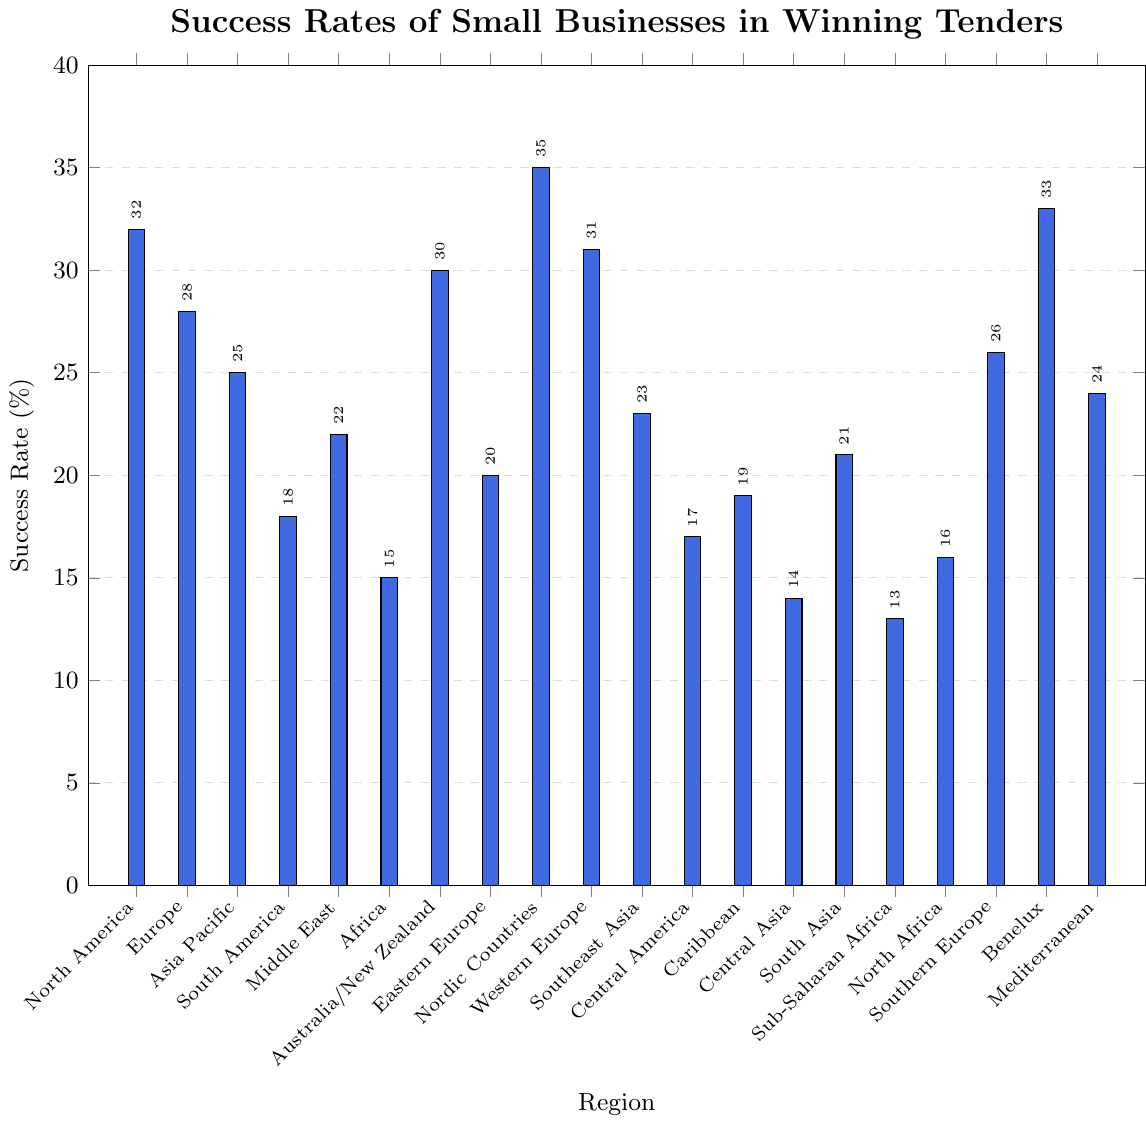Which region has the highest success rate in winning tenders? By looking at the tallest bar, we can identify the region with the highest success rate. The Nordic Countries have the tallest bar, indicating the highest success rate.
Answer: Nordic Countries Which regions have a success rate lower than 20%? To answer this, we compare the heights of the bars with the 20% mark. The regions with bars shorter than the 20% mark are South America, Africa, Eastern Europe, Central America, Central Asia, Sub-Saharan Africa, and North Africa.
Answer: South America, Africa, Eastern Europe, Central America, Central Asia, Sub-Saharan Africa, North Africa What is the combined success rate for North America and Benelux? The success rates for North America and Benelux are 32% and 33% respectively. Adding these values: 32 + 33 = 65.
Answer: 65% Which region has the lowest success rate and what is it? By identifying the shortest bar, we can determine the region with the lowest success rate. Sub-Saharan Africa has the shortest bar with a success rate of 13%.
Answer: Sub-Saharan Africa with 13% Are there more regions with success rates above or below 25%? We count the number of regions with bars taller than 25% and those with bars shorter than 25%. Regions above 25%: North America, Europe, Australia/New Zealand, Nordic Countries, Western Europe, Benelux, Southern Europe. Regions below 25%: Asia Pacific, South America, Middle East, Africa, Eastern Europe, Southeast Asia, Central America, Caribbean, Central Asia, South Asia, Sub-Saharan Africa, North Africa, Mediterranean. 7 regions are above, and 13 are below.
Answer: More are below 25% Which regions' success rates are exactly 20%? We search for the region with a bar height that aligns with the 20% mark. Eastern Europe has a success rate of exactly 20%.
Answer: Eastern Europe By how much does the success rate of North America exceed that of Central Asia? North America's success rate is 32%, and Central Asia's is 14%. Subtracting the smaller rate from the larger: 32 - 14 = 18.
Answer: 18% Which regions have similar success rates around 25% and what are those rates? We identify bars with heights close to 25%. Asia Pacific has 25%, Southeast Asia has 23%, the Middle East has 22%, and Mediterranean has 24%.
Answer: Asia Pacific (25%), Southeast Asia (23%), Middle East (22%), Mediterranean (24%) Compare the success rates of Southern Europe and Mediterranean. Which is higher and by how much? Southern Europe's success rate is 26%, and Mediterranean's is 24%. Subtracting Mediterranean's rate from Southern Europe's: 26 - 24 = 2. Southern Europe is 2% higher.
Answer: Southern Europe by 2% 